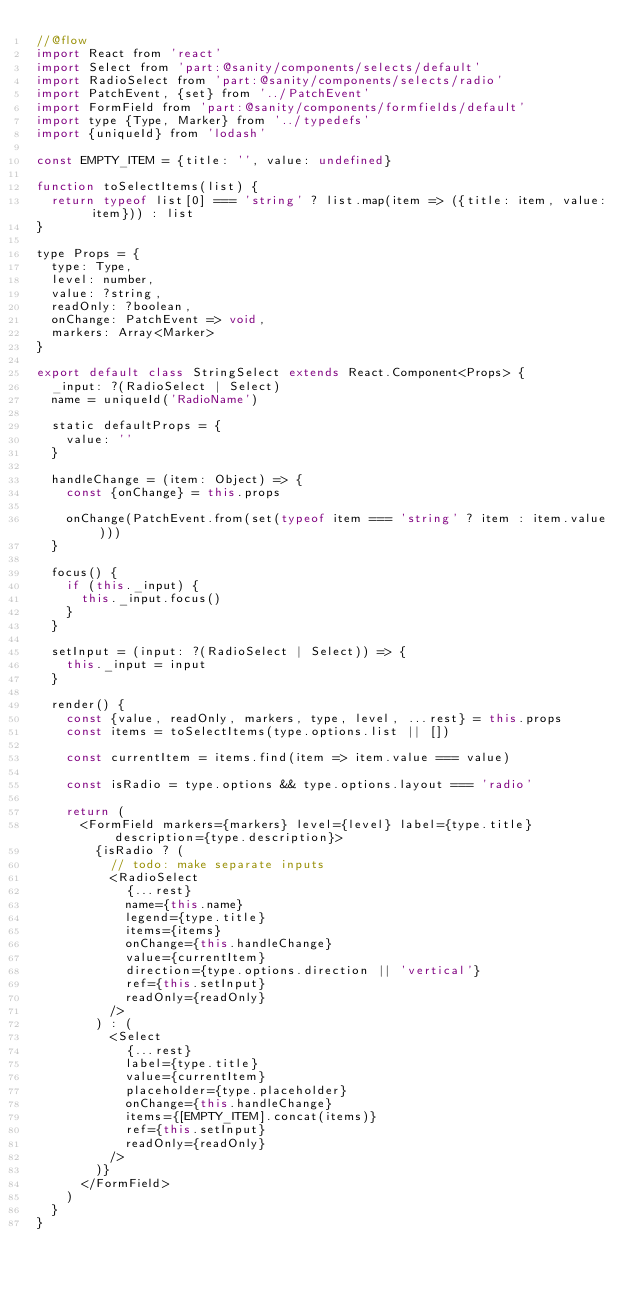Convert code to text. <code><loc_0><loc_0><loc_500><loc_500><_JavaScript_>//@flow
import React from 'react'
import Select from 'part:@sanity/components/selects/default'
import RadioSelect from 'part:@sanity/components/selects/radio'
import PatchEvent, {set} from '../PatchEvent'
import FormField from 'part:@sanity/components/formfields/default'
import type {Type, Marker} from '../typedefs'
import {uniqueId} from 'lodash'

const EMPTY_ITEM = {title: '', value: undefined}

function toSelectItems(list) {
  return typeof list[0] === 'string' ? list.map(item => ({title: item, value: item})) : list
}

type Props = {
  type: Type,
  level: number,
  value: ?string,
  readOnly: ?boolean,
  onChange: PatchEvent => void,
  markers: Array<Marker>
}

export default class StringSelect extends React.Component<Props> {
  _input: ?(RadioSelect | Select)
  name = uniqueId('RadioName')

  static defaultProps = {
    value: ''
  }

  handleChange = (item: Object) => {
    const {onChange} = this.props

    onChange(PatchEvent.from(set(typeof item === 'string' ? item : item.value)))
  }

  focus() {
    if (this._input) {
      this._input.focus()
    }
  }

  setInput = (input: ?(RadioSelect | Select)) => {
    this._input = input
  }

  render() {
    const {value, readOnly, markers, type, level, ...rest} = this.props
    const items = toSelectItems(type.options.list || [])

    const currentItem = items.find(item => item.value === value)

    const isRadio = type.options && type.options.layout === 'radio'

    return (
      <FormField markers={markers} level={level} label={type.title} description={type.description}>
        {isRadio ? (
          // todo: make separate inputs
          <RadioSelect
            {...rest}
            name={this.name}
            legend={type.title}
            items={items}
            onChange={this.handleChange}
            value={currentItem}
            direction={type.options.direction || 'vertical'}
            ref={this.setInput}
            readOnly={readOnly}
          />
        ) : (
          <Select
            {...rest}
            label={type.title}
            value={currentItem}
            placeholder={type.placeholder}
            onChange={this.handleChange}
            items={[EMPTY_ITEM].concat(items)}
            ref={this.setInput}
            readOnly={readOnly}
          />
        )}
      </FormField>
    )
  }
}
</code> 